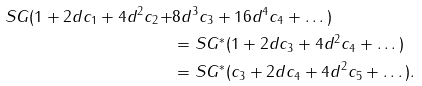Convert formula to latex. <formula><loc_0><loc_0><loc_500><loc_500>S G ( 1 + 2 d c _ { 1 } + 4 d ^ { 2 } c _ { 2 } + & 8 d ^ { 3 } c _ { 3 } + 1 6 d ^ { 4 } c _ { 4 } + \dots ) \\ & = S G ^ { * } ( 1 + 2 d c _ { 3 } + 4 d ^ { 2 } c _ { 4 } + \dots ) \\ & = S G ^ { * } ( c _ { 3 } + 2 d c _ { 4 } + 4 d ^ { 2 } c _ { 5 } + \dots ) .</formula> 